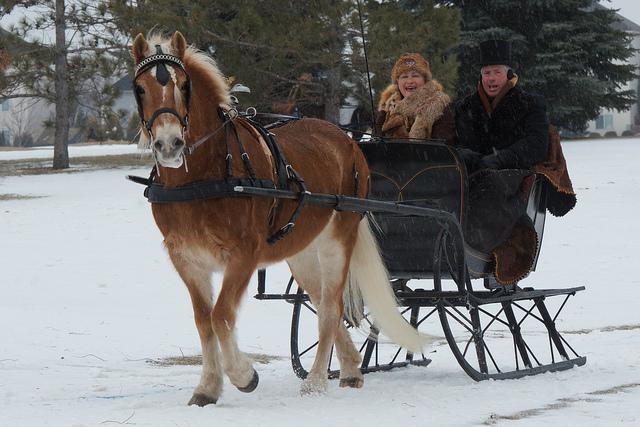What is the name of the horse drawn vehicle?
Short answer required. Sleigh. Is the woman crying?
Give a very brief answer. No. Is the horse black?
Write a very short answer. No. What is the horse pulling?
Give a very brief answer. Sled. 